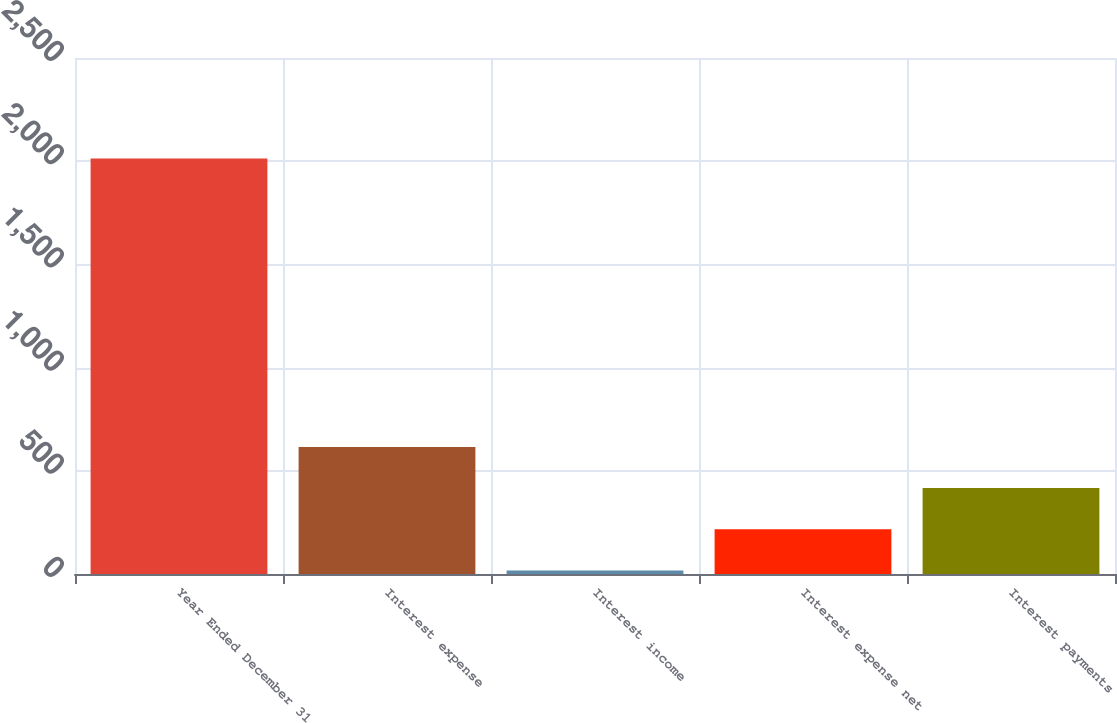<chart> <loc_0><loc_0><loc_500><loc_500><bar_chart><fcel>Year Ended December 31<fcel>Interest expense<fcel>Interest income<fcel>Interest expense net<fcel>Interest payments<nl><fcel>2013<fcel>615.8<fcel>17<fcel>216.6<fcel>416.2<nl></chart> 